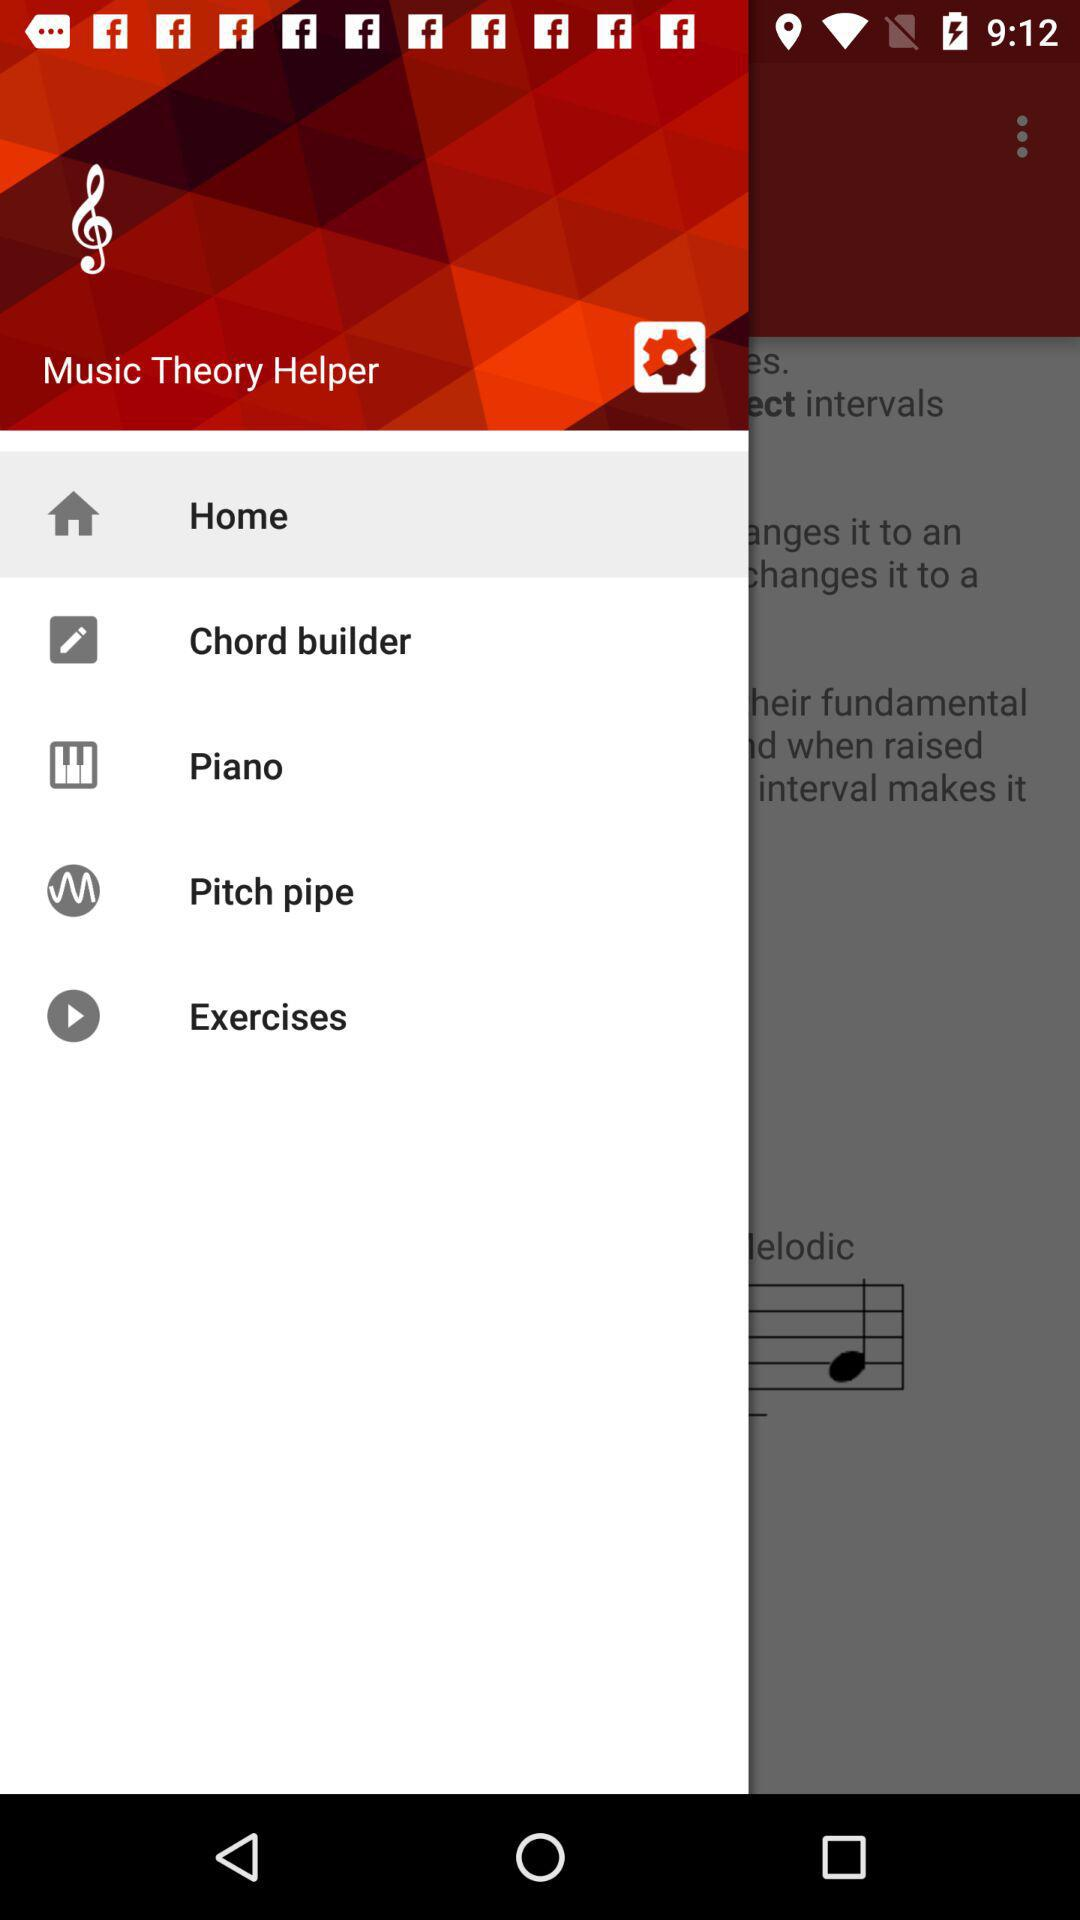What is the selected item in the menu? The selected item in the menu is "Home". 